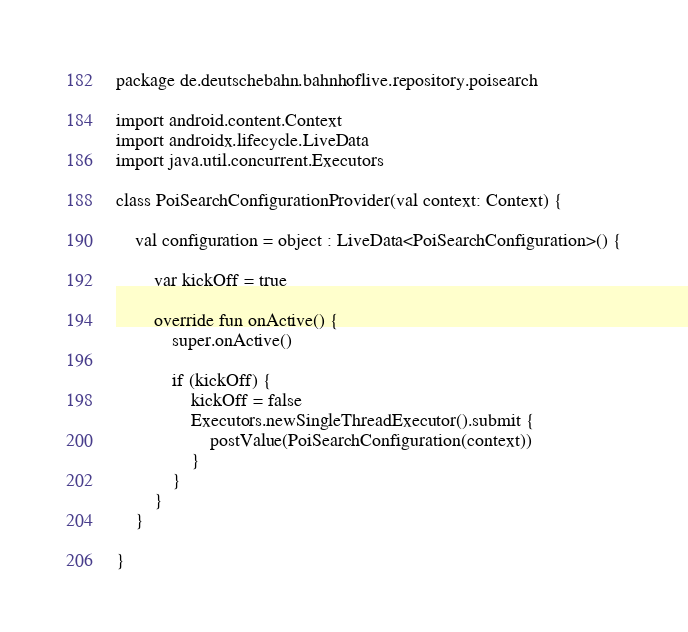<code> <loc_0><loc_0><loc_500><loc_500><_Kotlin_>package de.deutschebahn.bahnhoflive.repository.poisearch

import android.content.Context
import androidx.lifecycle.LiveData
import java.util.concurrent.Executors

class PoiSearchConfigurationProvider(val context: Context) {

    val configuration = object : LiveData<PoiSearchConfiguration>() {

        var kickOff = true

        override fun onActive() {
            super.onActive()

            if (kickOff) {
                kickOff = false
                Executors.newSingleThreadExecutor().submit {
                    postValue(PoiSearchConfiguration(context))
                }
            }
        }
    }

}</code> 